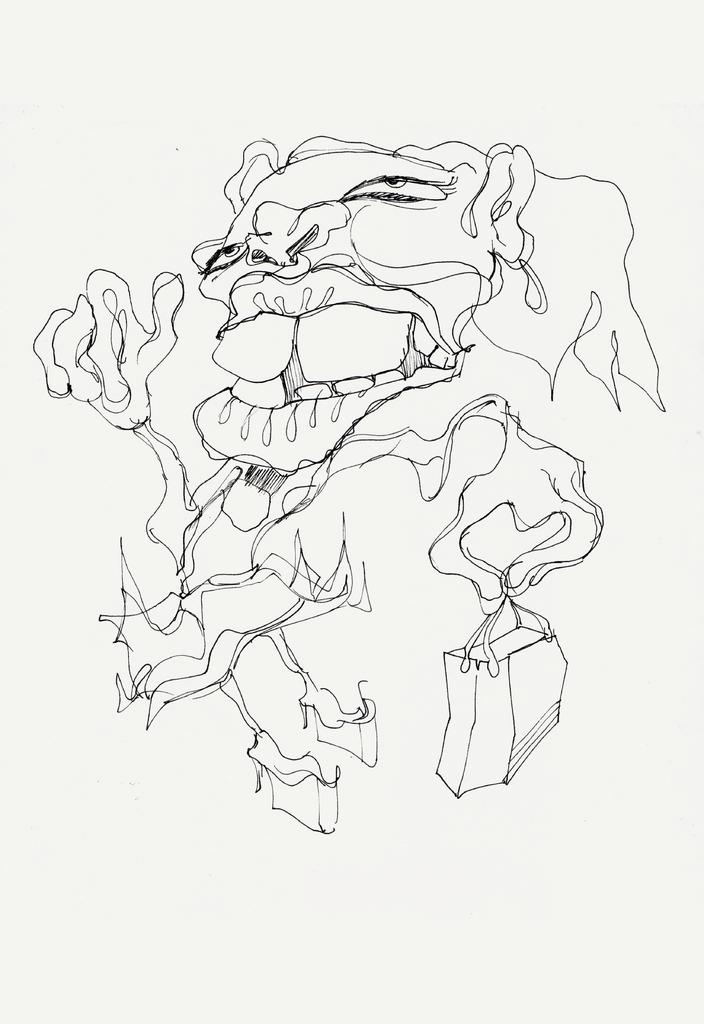What is depicted on the paper in the image? There is a drawing on a paper in the image. How many women are sitting on the branch in the image? There are no women or branches present in the image; it only features a drawing on a paper. 